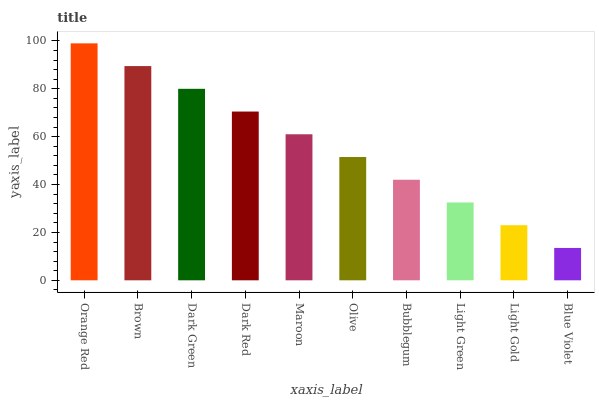Is Brown the minimum?
Answer yes or no. No. Is Brown the maximum?
Answer yes or no. No. Is Orange Red greater than Brown?
Answer yes or no. Yes. Is Brown less than Orange Red?
Answer yes or no. Yes. Is Brown greater than Orange Red?
Answer yes or no. No. Is Orange Red less than Brown?
Answer yes or no. No. Is Maroon the high median?
Answer yes or no. Yes. Is Olive the low median?
Answer yes or no. Yes. Is Dark Red the high median?
Answer yes or no. No. Is Bubblegum the low median?
Answer yes or no. No. 